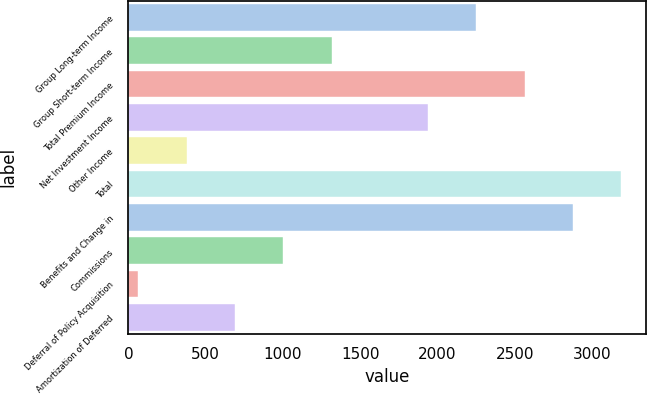Convert chart to OTSL. <chart><loc_0><loc_0><loc_500><loc_500><bar_chart><fcel>Group Long-term Income<fcel>Group Short-term Income<fcel>Total Premium Income<fcel>Net Investment Income<fcel>Other Income<fcel>Total<fcel>Benefits and Change in<fcel>Commissions<fcel>Deferral of Policy Acquisition<fcel>Amortization of Deferred<nl><fcel>2250.74<fcel>1313.78<fcel>2563.06<fcel>1938.42<fcel>376.82<fcel>3187.7<fcel>2875.38<fcel>1001.46<fcel>64.5<fcel>689.14<nl></chart> 